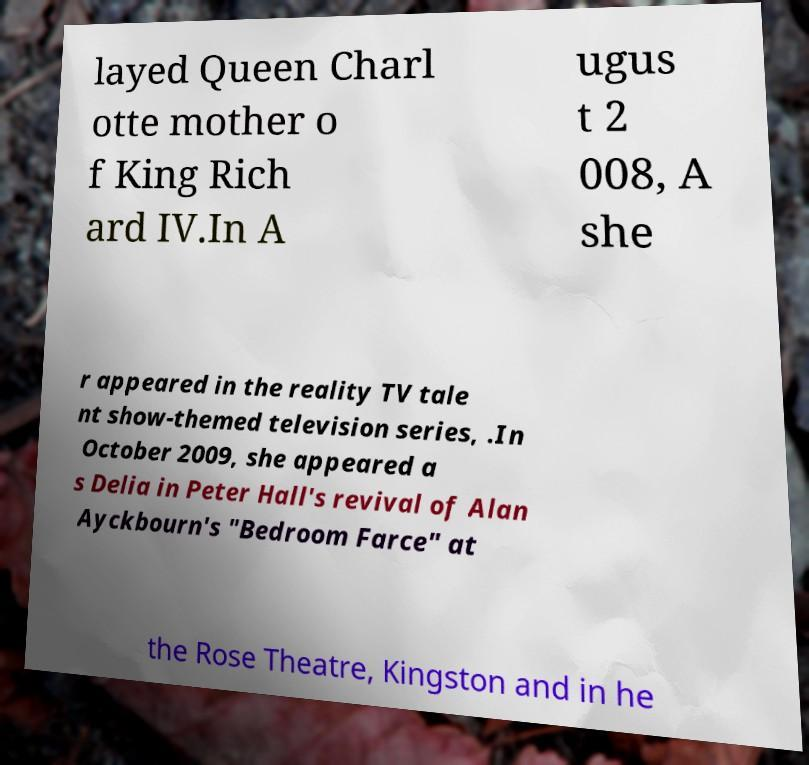Can you read and provide the text displayed in the image?This photo seems to have some interesting text. Can you extract and type it out for me? layed Queen Charl otte mother o f King Rich ard IV.In A ugus t 2 008, A she r appeared in the reality TV tale nt show-themed television series, .In October 2009, she appeared a s Delia in Peter Hall's revival of Alan Ayckbourn's "Bedroom Farce" at the Rose Theatre, Kingston and in he 